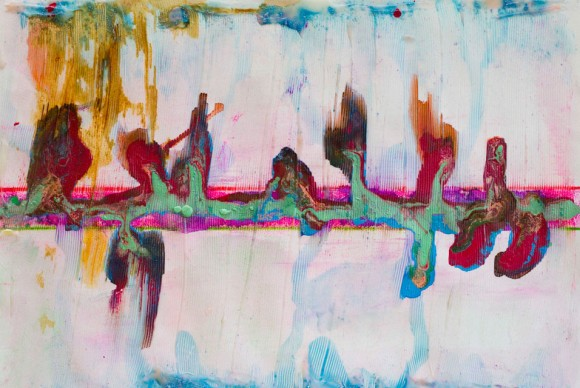If this abstract painting could tell a story, what do you think it would be? The abstract painting narrates a story of a journey through a surreal landscape. The pastel colors symbolize the gentle beginnings, where everything is calm and serene. As one progresses, the darker hues represent challenges and obstacles that add depth to this journey. The flowing shapes could be interpreted as barriers and pathways that change direction, symbolizing the unpredictable nature of life's path. The blending of colors and forms depicts the interconnectedness of experiences, suggesting that every twist and turn, every high and low, contributes to a unique and complex life story. Imagine this artwork came to life and became a scene in a fantasy world. Describe what you see. In a fantasy world brought to life by this artwork, the landscape is a mesmerizing blend of fluid forms and shifting colors. The pastel sky stretches endlessly, with wisps of pink, blue, and green intertwining like gentle streams. Majestic, otherworldly creatures with flowing, abstract bodies glide gracefully through the air, leaving trails of color in their wake. The ground below is a vast, undulating terrain, where every step causes ripples of color to spread outwards, creating constantly changing scenery. Ethereal trees with branches that stretch like tendrils reach towards the sky, their leaves shimmering with every conceivable hue. This world is in perpetual motion, a living painting where the boundary between the real and the surreal ceases to exist. 